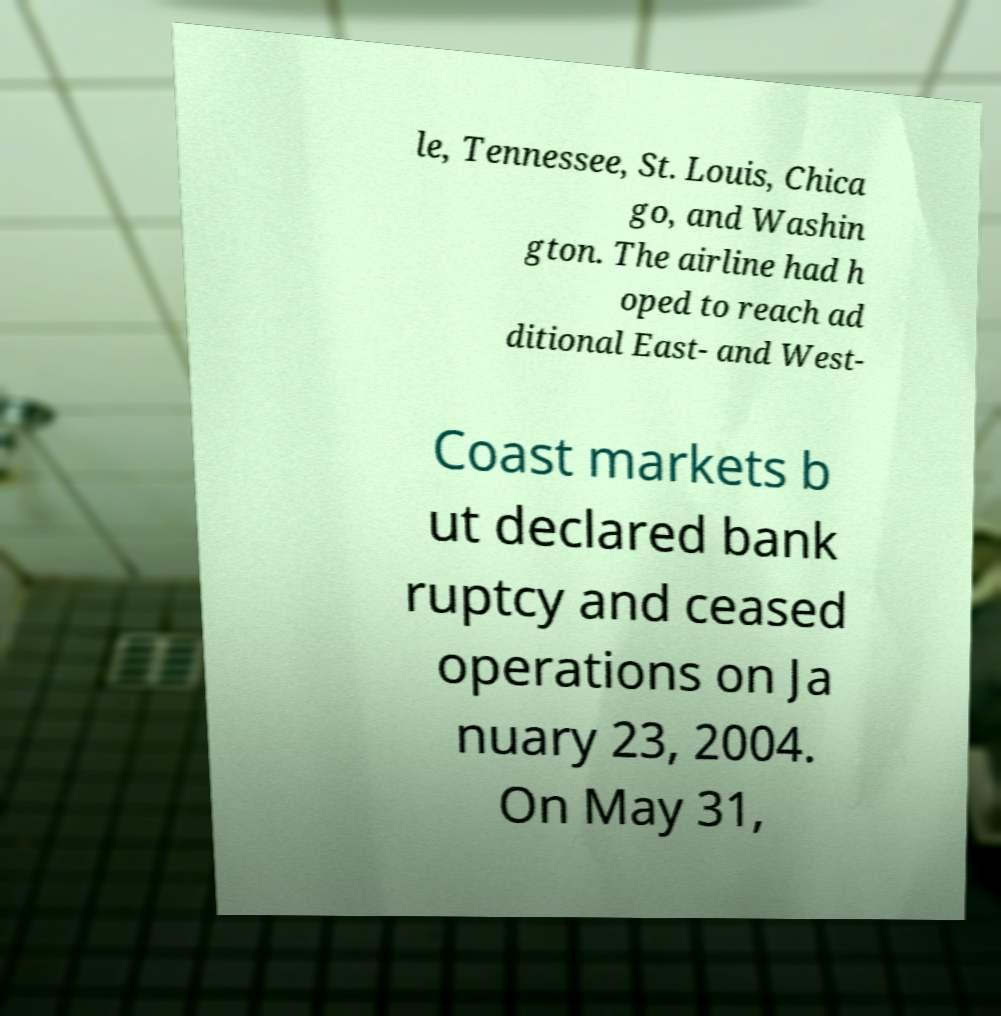Please identify and transcribe the text found in this image. le, Tennessee, St. Louis, Chica go, and Washin gton. The airline had h oped to reach ad ditional East- and West- Coast markets b ut declared bank ruptcy and ceased operations on Ja nuary 23, 2004. On May 31, 